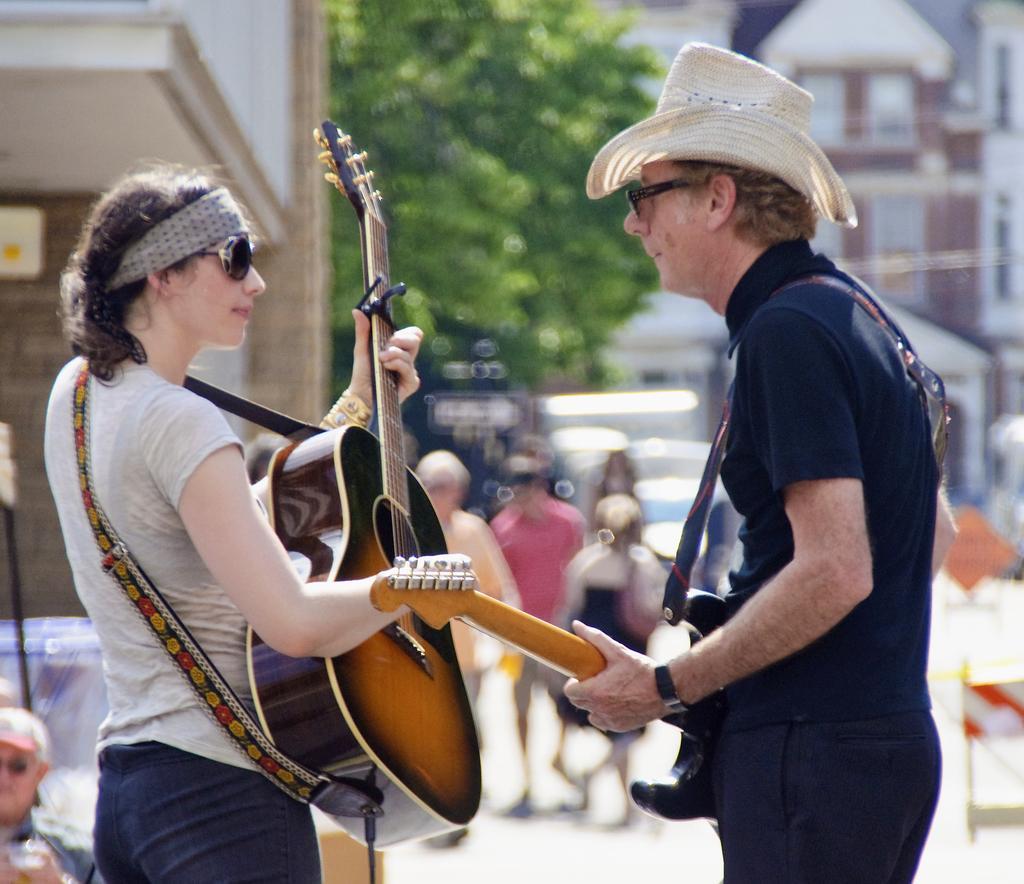Please provide a concise description of this image. There is men and women holding guitars and standing. At background I can see few people standing. There is a tree and Buildings. 